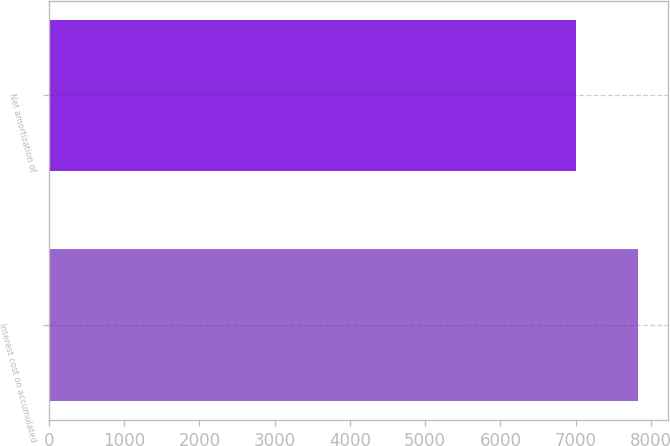Convert chart to OTSL. <chart><loc_0><loc_0><loc_500><loc_500><bar_chart><fcel>Interest cost on accumulated<fcel>Net amortization of<nl><fcel>7828<fcel>7002<nl></chart> 